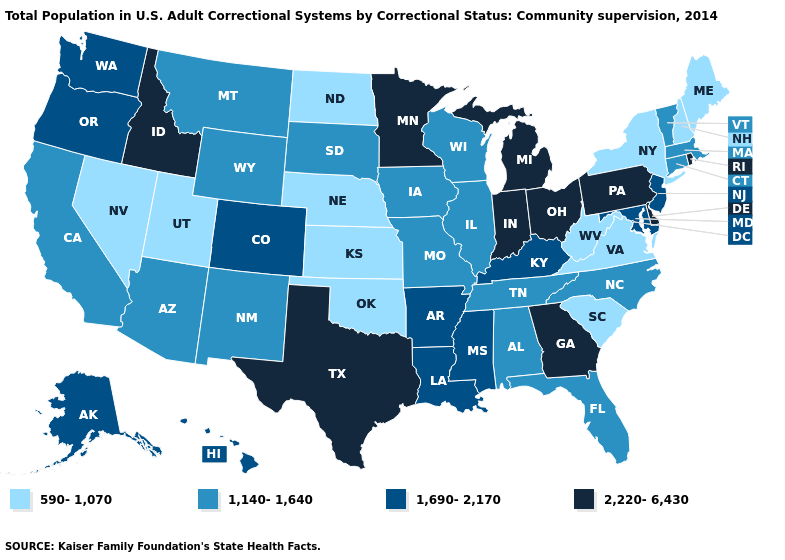Among the states that border North Dakota , does Montana have the highest value?
Concise answer only. No. Does the first symbol in the legend represent the smallest category?
Answer briefly. Yes. Which states have the lowest value in the USA?
Give a very brief answer. Kansas, Maine, Nebraska, Nevada, New Hampshire, New York, North Dakota, Oklahoma, South Carolina, Utah, Virginia, West Virginia. Among the states that border Alabama , does Mississippi have the lowest value?
Short answer required. No. Does New Hampshire have the lowest value in the USA?
Write a very short answer. Yes. What is the lowest value in the MidWest?
Give a very brief answer. 590-1,070. Does Rhode Island have the highest value in the Northeast?
Short answer required. Yes. Which states have the lowest value in the USA?
Be succinct. Kansas, Maine, Nebraska, Nevada, New Hampshire, New York, North Dakota, Oklahoma, South Carolina, Utah, Virginia, West Virginia. What is the value of Missouri?
Be succinct. 1,140-1,640. Among the states that border Arkansas , which have the lowest value?
Answer briefly. Oklahoma. Among the states that border Minnesota , which have the highest value?
Short answer required. Iowa, South Dakota, Wisconsin. Is the legend a continuous bar?
Write a very short answer. No. Does Iowa have a lower value than Kansas?
Short answer required. No. Which states have the lowest value in the MidWest?
Concise answer only. Kansas, Nebraska, North Dakota. Does Minnesota have the same value as Indiana?
Keep it brief. Yes. 